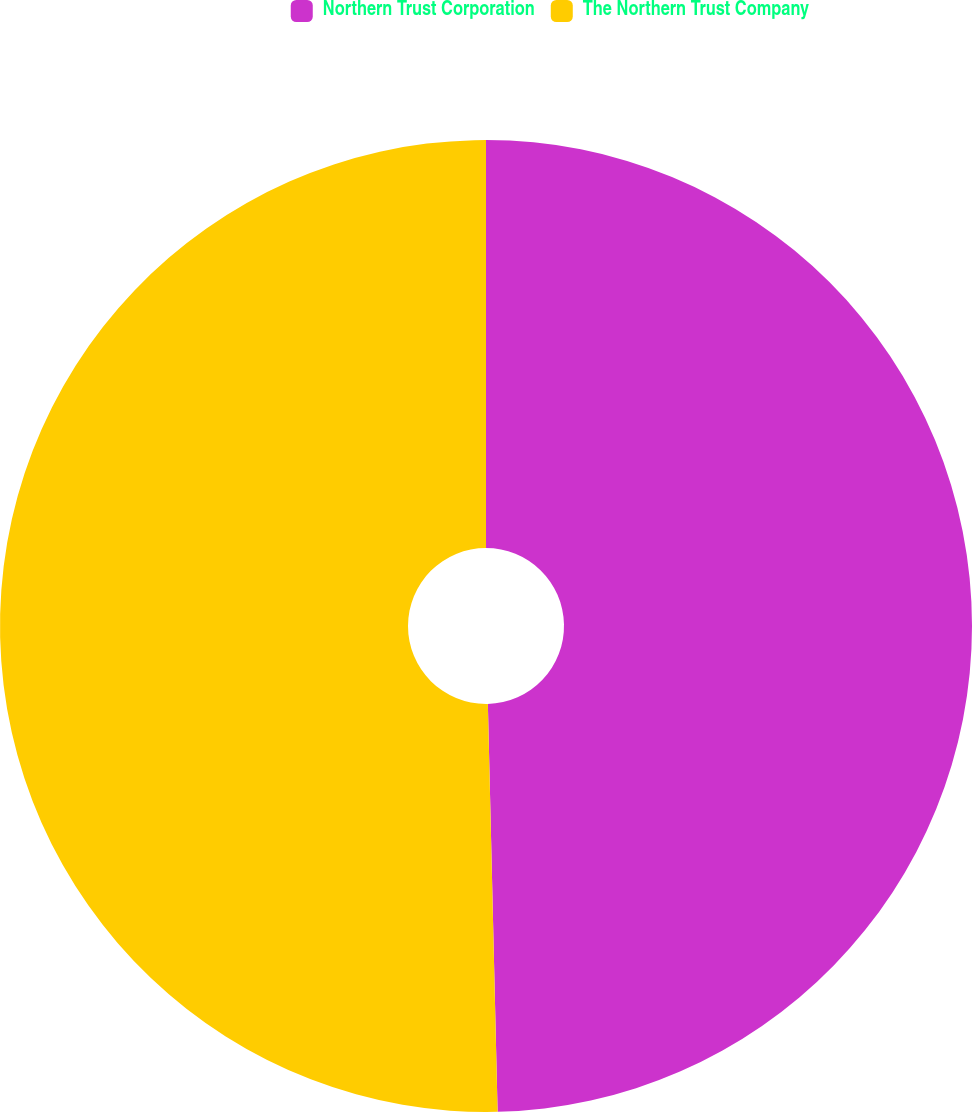<chart> <loc_0><loc_0><loc_500><loc_500><pie_chart><fcel>Northern Trust Corporation<fcel>The Northern Trust Company<nl><fcel>49.62%<fcel>50.38%<nl></chart> 